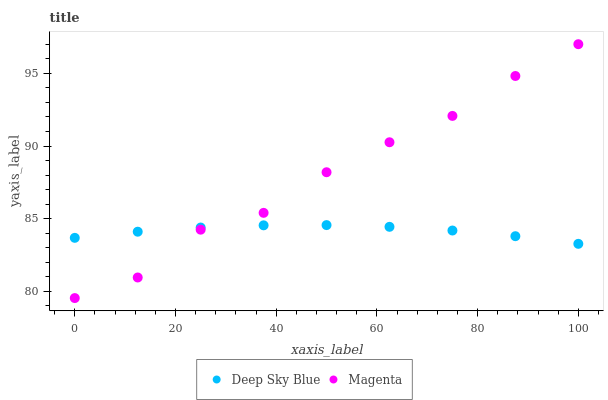Does Deep Sky Blue have the minimum area under the curve?
Answer yes or no. Yes. Does Magenta have the maximum area under the curve?
Answer yes or no. Yes. Does Deep Sky Blue have the maximum area under the curve?
Answer yes or no. No. Is Deep Sky Blue the smoothest?
Answer yes or no. Yes. Is Magenta the roughest?
Answer yes or no. Yes. Is Deep Sky Blue the roughest?
Answer yes or no. No. Does Magenta have the lowest value?
Answer yes or no. Yes. Does Deep Sky Blue have the lowest value?
Answer yes or no. No. Does Magenta have the highest value?
Answer yes or no. Yes. Does Deep Sky Blue have the highest value?
Answer yes or no. No. Does Deep Sky Blue intersect Magenta?
Answer yes or no. Yes. Is Deep Sky Blue less than Magenta?
Answer yes or no. No. Is Deep Sky Blue greater than Magenta?
Answer yes or no. No. 